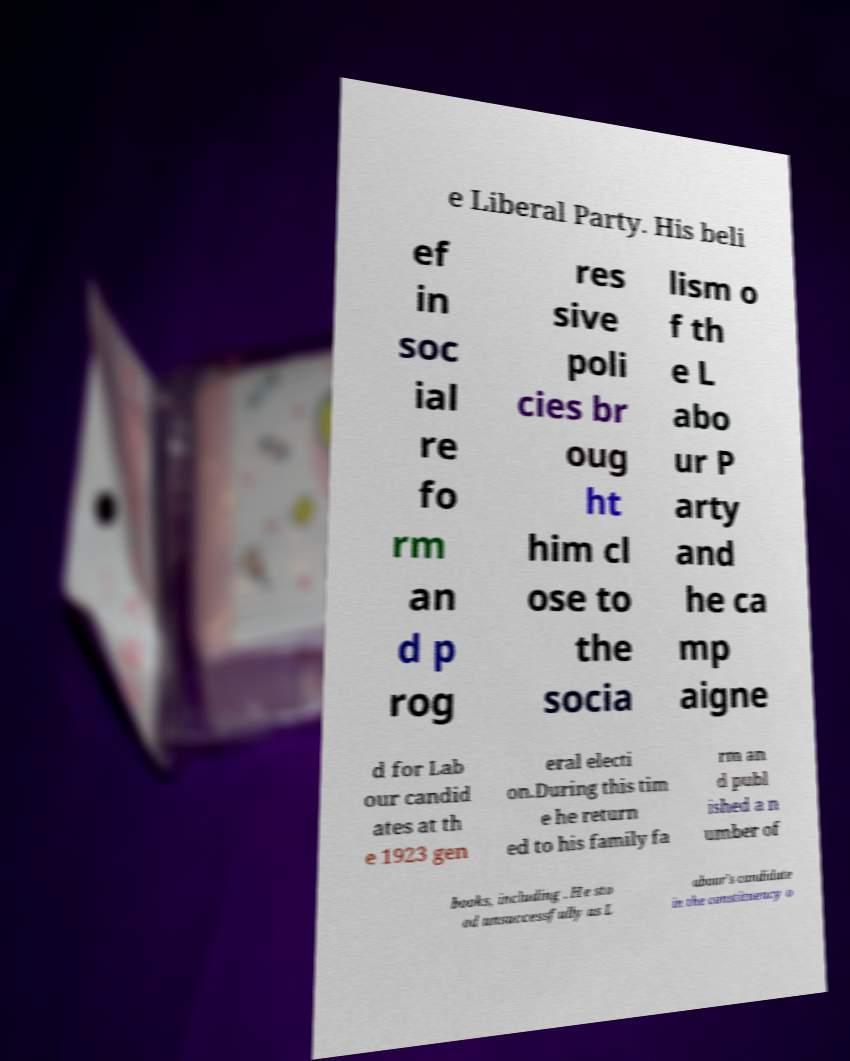Please read and relay the text visible in this image. What does it say? e Liberal Party. His beli ef in soc ial re fo rm an d p rog res sive poli cies br oug ht him cl ose to the socia lism o f th e L abo ur P arty and he ca mp aigne d for Lab our candid ates at th e 1923 gen eral electi on.During this tim e he return ed to his family fa rm an d publ ished a n umber of books, including . He sto od unsuccessfully as L abour's candidate in the constituency o 